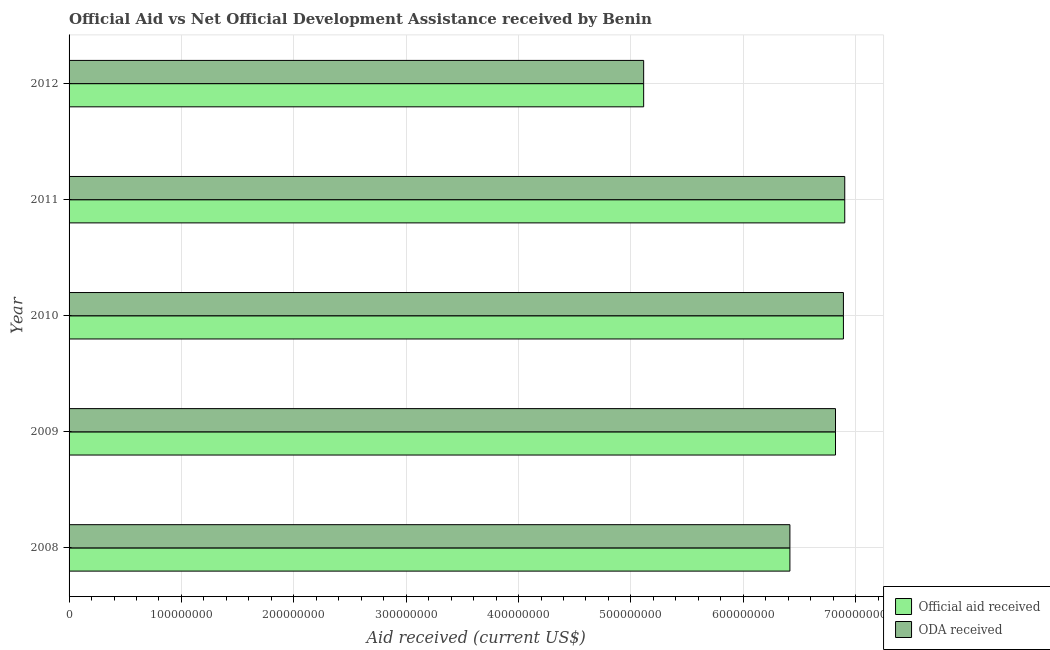How many groups of bars are there?
Ensure brevity in your answer.  5. Are the number of bars per tick equal to the number of legend labels?
Offer a very short reply. Yes. Are the number of bars on each tick of the Y-axis equal?
Offer a very short reply. Yes. How many bars are there on the 4th tick from the bottom?
Provide a short and direct response. 2. What is the label of the 4th group of bars from the top?
Provide a succinct answer. 2009. In how many cases, is the number of bars for a given year not equal to the number of legend labels?
Your response must be concise. 0. What is the oda received in 2010?
Give a very brief answer. 6.89e+08. Across all years, what is the maximum oda received?
Offer a very short reply. 6.90e+08. Across all years, what is the minimum official aid received?
Provide a succinct answer. 5.11e+08. What is the total official aid received in the graph?
Offer a very short reply. 3.21e+09. What is the difference between the official aid received in 2008 and that in 2012?
Provide a short and direct response. 1.30e+08. What is the difference between the oda received in 2008 and the official aid received in 2011?
Provide a succinct answer. -4.88e+07. What is the average official aid received per year?
Ensure brevity in your answer.  6.43e+08. In the year 2008, what is the difference between the oda received and official aid received?
Keep it short and to the point. 0. What is the ratio of the oda received in 2010 to that in 2011?
Offer a very short reply. 1. Is the oda received in 2008 less than that in 2010?
Provide a short and direct response. Yes. What is the difference between the highest and the second highest official aid received?
Your response must be concise. 1.18e+06. What is the difference between the highest and the lowest oda received?
Make the answer very short. 1.79e+08. In how many years, is the oda received greater than the average oda received taken over all years?
Give a very brief answer. 3. Is the sum of the oda received in 2010 and 2012 greater than the maximum official aid received across all years?
Offer a terse response. Yes. What does the 2nd bar from the top in 2009 represents?
Provide a succinct answer. Official aid received. What does the 1st bar from the bottom in 2012 represents?
Ensure brevity in your answer.  Official aid received. Are all the bars in the graph horizontal?
Ensure brevity in your answer.  Yes. What is the difference between two consecutive major ticks on the X-axis?
Provide a short and direct response. 1.00e+08. Does the graph contain any zero values?
Offer a very short reply. No. Where does the legend appear in the graph?
Provide a short and direct response. Bottom right. How many legend labels are there?
Offer a terse response. 2. How are the legend labels stacked?
Your answer should be compact. Vertical. What is the title of the graph?
Offer a terse response. Official Aid vs Net Official Development Assistance received by Benin . What is the label or title of the X-axis?
Your answer should be very brief. Aid received (current US$). What is the label or title of the Y-axis?
Make the answer very short. Year. What is the Aid received (current US$) of Official aid received in 2008?
Keep it short and to the point. 6.41e+08. What is the Aid received (current US$) in ODA received in 2008?
Make the answer very short. 6.41e+08. What is the Aid received (current US$) in Official aid received in 2009?
Make the answer very short. 6.82e+08. What is the Aid received (current US$) of ODA received in 2009?
Provide a succinct answer. 6.82e+08. What is the Aid received (current US$) of Official aid received in 2010?
Your answer should be compact. 6.89e+08. What is the Aid received (current US$) of ODA received in 2010?
Offer a very short reply. 6.89e+08. What is the Aid received (current US$) in Official aid received in 2011?
Your answer should be compact. 6.90e+08. What is the Aid received (current US$) of ODA received in 2011?
Offer a very short reply. 6.90e+08. What is the Aid received (current US$) of Official aid received in 2012?
Make the answer very short. 5.11e+08. What is the Aid received (current US$) of ODA received in 2012?
Make the answer very short. 5.11e+08. Across all years, what is the maximum Aid received (current US$) in Official aid received?
Your answer should be compact. 6.90e+08. Across all years, what is the maximum Aid received (current US$) in ODA received?
Provide a short and direct response. 6.90e+08. Across all years, what is the minimum Aid received (current US$) in Official aid received?
Offer a very short reply. 5.11e+08. Across all years, what is the minimum Aid received (current US$) of ODA received?
Provide a succinct answer. 5.11e+08. What is the total Aid received (current US$) in Official aid received in the graph?
Ensure brevity in your answer.  3.21e+09. What is the total Aid received (current US$) in ODA received in the graph?
Provide a short and direct response. 3.21e+09. What is the difference between the Aid received (current US$) in Official aid received in 2008 and that in 2009?
Give a very brief answer. -4.06e+07. What is the difference between the Aid received (current US$) in ODA received in 2008 and that in 2009?
Offer a very short reply. -4.06e+07. What is the difference between the Aid received (current US$) in Official aid received in 2008 and that in 2010?
Offer a terse response. -4.76e+07. What is the difference between the Aid received (current US$) in ODA received in 2008 and that in 2010?
Your answer should be compact. -4.76e+07. What is the difference between the Aid received (current US$) of Official aid received in 2008 and that in 2011?
Provide a short and direct response. -4.88e+07. What is the difference between the Aid received (current US$) of ODA received in 2008 and that in 2011?
Keep it short and to the point. -4.88e+07. What is the difference between the Aid received (current US$) of Official aid received in 2008 and that in 2012?
Give a very brief answer. 1.30e+08. What is the difference between the Aid received (current US$) in ODA received in 2008 and that in 2012?
Offer a very short reply. 1.30e+08. What is the difference between the Aid received (current US$) of Official aid received in 2009 and that in 2010?
Give a very brief answer. -7.06e+06. What is the difference between the Aid received (current US$) of ODA received in 2009 and that in 2010?
Your response must be concise. -7.06e+06. What is the difference between the Aid received (current US$) in Official aid received in 2009 and that in 2011?
Your response must be concise. -8.24e+06. What is the difference between the Aid received (current US$) of ODA received in 2009 and that in 2011?
Provide a short and direct response. -8.24e+06. What is the difference between the Aid received (current US$) of Official aid received in 2009 and that in 2012?
Make the answer very short. 1.71e+08. What is the difference between the Aid received (current US$) of ODA received in 2009 and that in 2012?
Your answer should be compact. 1.71e+08. What is the difference between the Aid received (current US$) of Official aid received in 2010 and that in 2011?
Make the answer very short. -1.18e+06. What is the difference between the Aid received (current US$) in ODA received in 2010 and that in 2011?
Give a very brief answer. -1.18e+06. What is the difference between the Aid received (current US$) in Official aid received in 2010 and that in 2012?
Your response must be concise. 1.78e+08. What is the difference between the Aid received (current US$) in ODA received in 2010 and that in 2012?
Make the answer very short. 1.78e+08. What is the difference between the Aid received (current US$) of Official aid received in 2011 and that in 2012?
Your answer should be compact. 1.79e+08. What is the difference between the Aid received (current US$) in ODA received in 2011 and that in 2012?
Offer a terse response. 1.79e+08. What is the difference between the Aid received (current US$) in Official aid received in 2008 and the Aid received (current US$) in ODA received in 2009?
Your answer should be very brief. -4.06e+07. What is the difference between the Aid received (current US$) in Official aid received in 2008 and the Aid received (current US$) in ODA received in 2010?
Provide a succinct answer. -4.76e+07. What is the difference between the Aid received (current US$) in Official aid received in 2008 and the Aid received (current US$) in ODA received in 2011?
Offer a very short reply. -4.88e+07. What is the difference between the Aid received (current US$) in Official aid received in 2008 and the Aid received (current US$) in ODA received in 2012?
Make the answer very short. 1.30e+08. What is the difference between the Aid received (current US$) of Official aid received in 2009 and the Aid received (current US$) of ODA received in 2010?
Your response must be concise. -7.06e+06. What is the difference between the Aid received (current US$) in Official aid received in 2009 and the Aid received (current US$) in ODA received in 2011?
Your answer should be compact. -8.24e+06. What is the difference between the Aid received (current US$) in Official aid received in 2009 and the Aid received (current US$) in ODA received in 2012?
Provide a succinct answer. 1.71e+08. What is the difference between the Aid received (current US$) of Official aid received in 2010 and the Aid received (current US$) of ODA received in 2011?
Offer a very short reply. -1.18e+06. What is the difference between the Aid received (current US$) in Official aid received in 2010 and the Aid received (current US$) in ODA received in 2012?
Provide a succinct answer. 1.78e+08. What is the difference between the Aid received (current US$) of Official aid received in 2011 and the Aid received (current US$) of ODA received in 2012?
Your answer should be compact. 1.79e+08. What is the average Aid received (current US$) in Official aid received per year?
Offer a very short reply. 6.43e+08. What is the average Aid received (current US$) of ODA received per year?
Offer a terse response. 6.43e+08. What is the ratio of the Aid received (current US$) in Official aid received in 2008 to that in 2009?
Ensure brevity in your answer.  0.94. What is the ratio of the Aid received (current US$) in ODA received in 2008 to that in 2009?
Your answer should be very brief. 0.94. What is the ratio of the Aid received (current US$) in Official aid received in 2008 to that in 2010?
Give a very brief answer. 0.93. What is the ratio of the Aid received (current US$) in ODA received in 2008 to that in 2010?
Your answer should be compact. 0.93. What is the ratio of the Aid received (current US$) in Official aid received in 2008 to that in 2011?
Your answer should be compact. 0.93. What is the ratio of the Aid received (current US$) of ODA received in 2008 to that in 2011?
Give a very brief answer. 0.93. What is the ratio of the Aid received (current US$) of Official aid received in 2008 to that in 2012?
Your response must be concise. 1.25. What is the ratio of the Aid received (current US$) in ODA received in 2008 to that in 2012?
Give a very brief answer. 1.25. What is the ratio of the Aid received (current US$) of Official aid received in 2009 to that in 2010?
Your answer should be very brief. 0.99. What is the ratio of the Aid received (current US$) of ODA received in 2009 to that in 2010?
Offer a very short reply. 0.99. What is the ratio of the Aid received (current US$) in Official aid received in 2009 to that in 2012?
Keep it short and to the point. 1.33. What is the ratio of the Aid received (current US$) of ODA received in 2009 to that in 2012?
Provide a succinct answer. 1.33. What is the ratio of the Aid received (current US$) of Official aid received in 2010 to that in 2011?
Give a very brief answer. 1. What is the ratio of the Aid received (current US$) of Official aid received in 2010 to that in 2012?
Give a very brief answer. 1.35. What is the ratio of the Aid received (current US$) in ODA received in 2010 to that in 2012?
Ensure brevity in your answer.  1.35. What is the ratio of the Aid received (current US$) of Official aid received in 2011 to that in 2012?
Your answer should be very brief. 1.35. What is the ratio of the Aid received (current US$) of ODA received in 2011 to that in 2012?
Give a very brief answer. 1.35. What is the difference between the highest and the second highest Aid received (current US$) in Official aid received?
Make the answer very short. 1.18e+06. What is the difference between the highest and the second highest Aid received (current US$) of ODA received?
Ensure brevity in your answer.  1.18e+06. What is the difference between the highest and the lowest Aid received (current US$) in Official aid received?
Provide a short and direct response. 1.79e+08. What is the difference between the highest and the lowest Aid received (current US$) of ODA received?
Offer a terse response. 1.79e+08. 